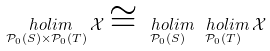Convert formula to latex. <formula><loc_0><loc_0><loc_500><loc_500>\underset { \mathcal { P } _ { 0 } ( S ) \times \mathcal { P } _ { 0 } ( T ) } { \ h o l i m } \, \mathcal { X } \cong \underset { \mathcal { P } _ { 0 } ( S ) } { \ h o l i m } \, \underset { \mathcal { P } _ { 0 } ( T ) } { \ h o l i m } \, \mathcal { X }</formula> 